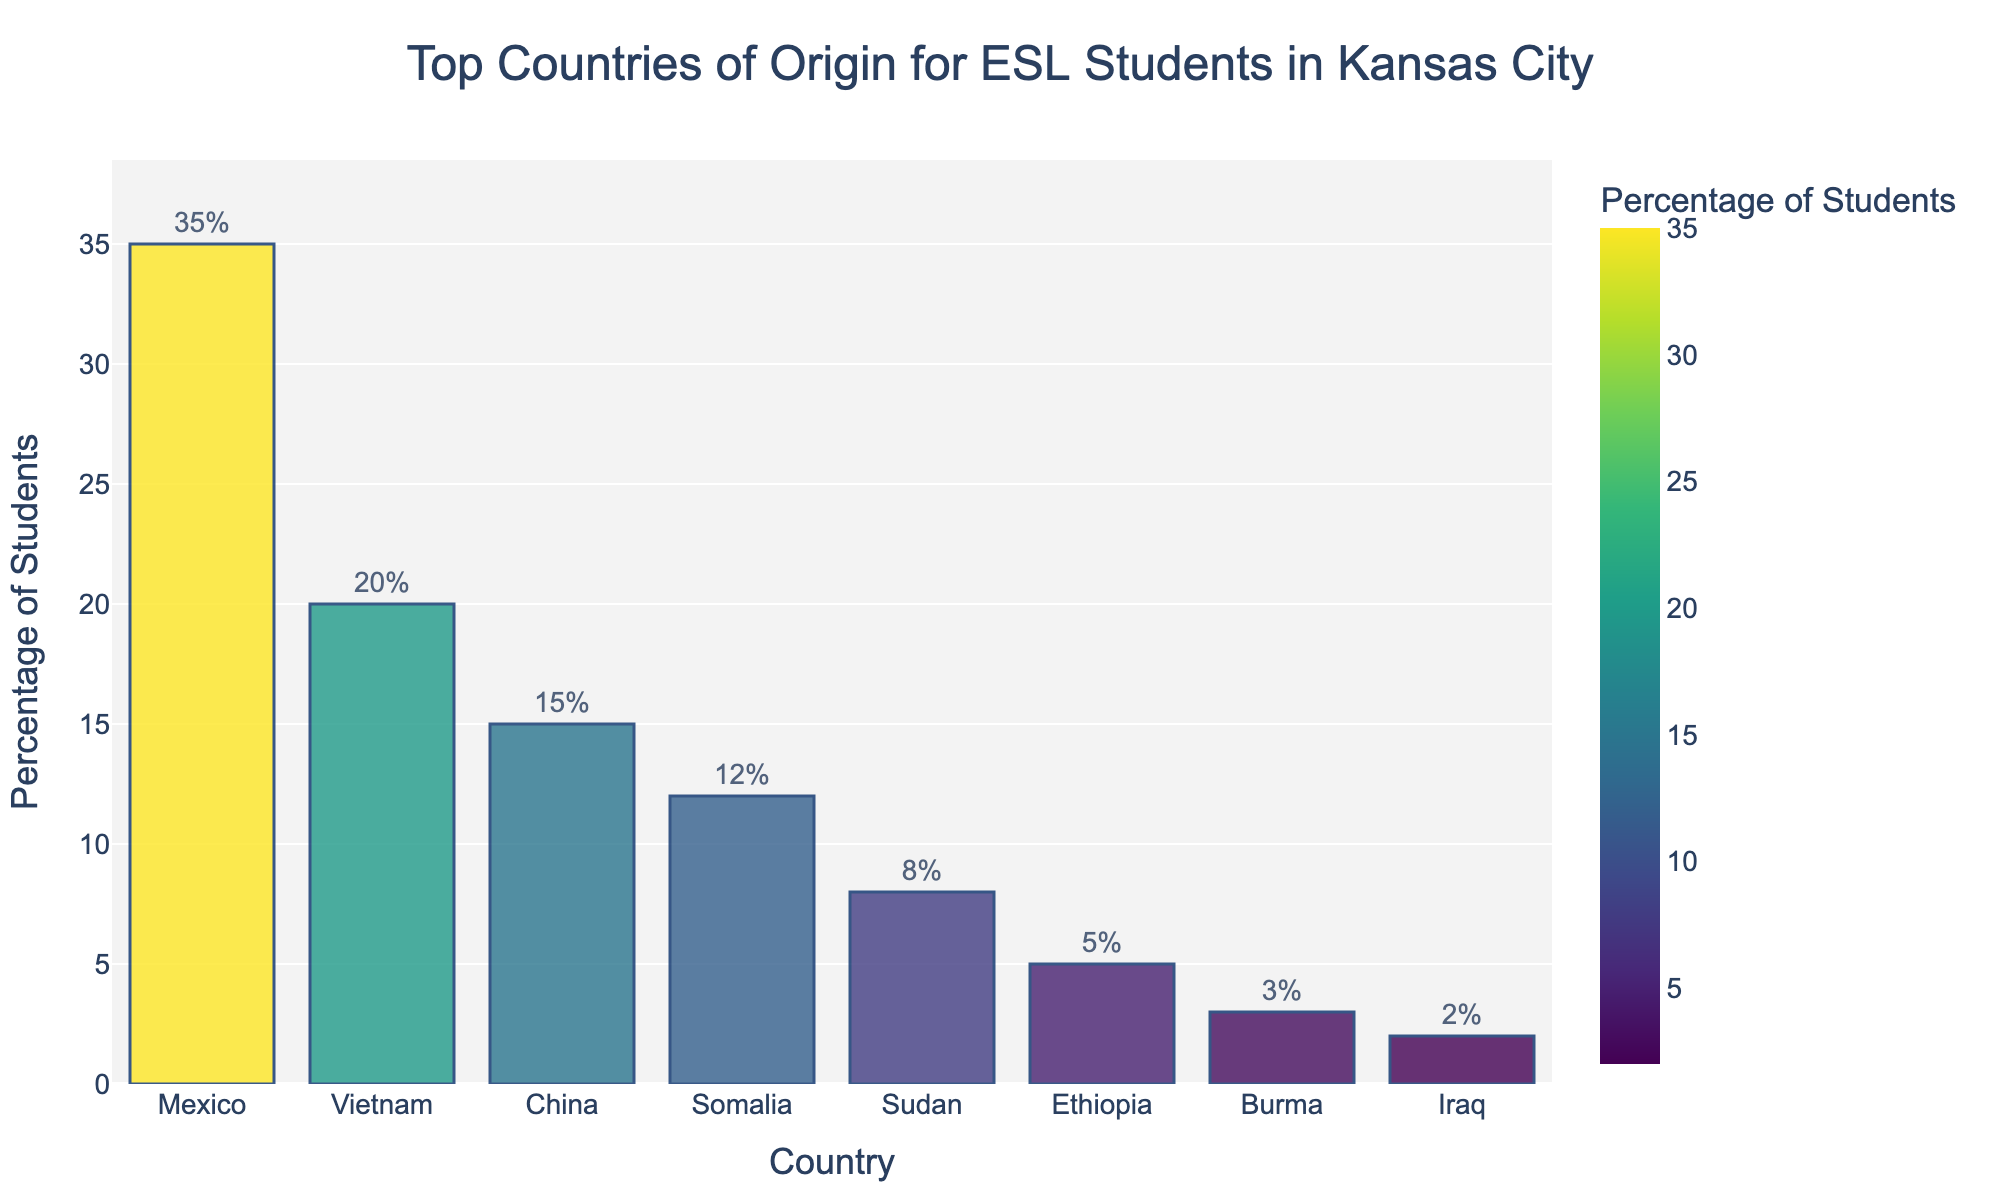What is the most common country of origin for ESL students in Kansas City? Mexico has the highest percentage among the listed countries at 35%, making it the most common country of origin.
Answer: Mexico Which country has a higher percentage of ESL students, China or Vietnam? Vietnam has a higher percentage (20%) compared to China (15%).
Answer: Vietnam What is the combined percentage of ESL students from Sudan and Somalia? The percentage of ESL students from Sudan is 8% and from Somalia is 12%. Adding these together gives 8% + 12% = 20%.
Answer: 20% Which two countries have the smallest percentages of ESL students, and what are their respective percentages? The two countries with the smallest percentages of ESL students are Iraq (2%) and Burma (3%).
Answer: Iraq (2%), Burma (3%) What is the overall percentage of ESL students from the top three countries combined? The top three countries are Mexico (35%), Vietnam (20%), and China (15%). Adding these percentages together gives 35% + 20% + 15% = 70%.
Answer: 70% Comparing the countries of Mexico and Ethiopia, how many more ESL students are from Mexico than Ethiopia, in percentage points? The percentage for Mexico is 35%, and for Ethiopia, it is 5%. The difference is 35% - 5% = 30 percentage points.
Answer: 30 percentage points How much greater is the percentage of ESL students from Vietnam compared to Sudan? Vietnam has 20% and Sudan has 8%. The difference is 20% - 8% = 12%.
Answer: 12% Which country has the shortest bar in the bar chart? Iraq has the shortest bar with a percentage of 2%.
Answer: Iraq Is the proportion of ESL students from China higher or lower than that of students from Somalia and Sudan combined? The combined percentage for Somalia (12%) and Sudan (8%) is 12% + 8% = 20%, which is higher than China's 15%.
Answer: Lower If we exclude the top three countries, what is the average percentage of the remaining countries? The remaining countries are Somalia (12%), Sudan (8%), Ethiopia (5%), Burma (3%), and Iraq (2%). The sum of their percentages is 12% + 8% + 5% + 3% + 2% = 30%. There are 5 countries, so the average is 30% / 5 = 6%.
Answer: 6% 